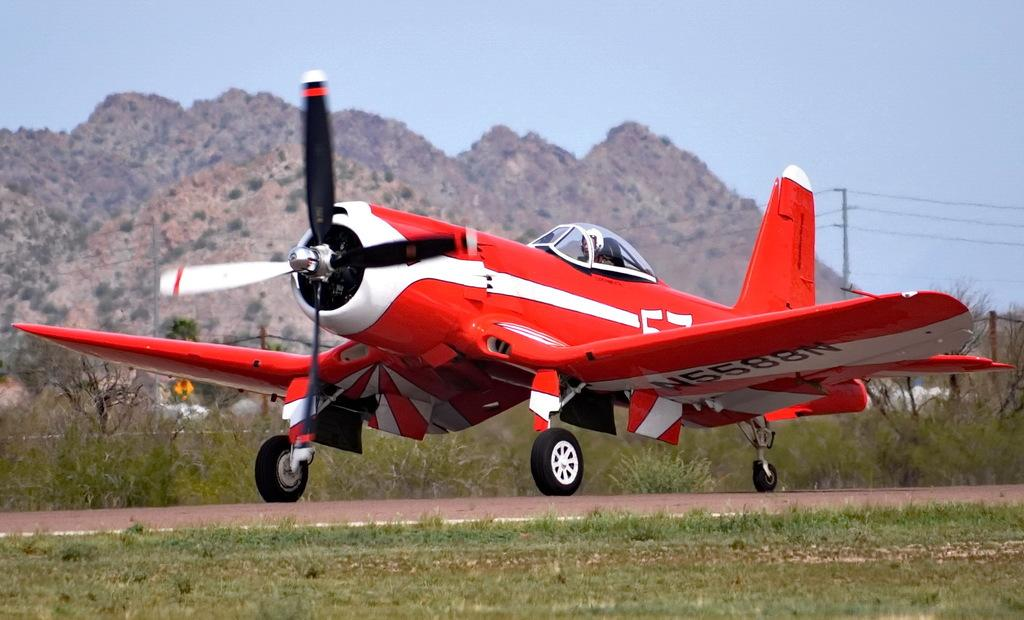Provide a one-sentence caption for the provided image. The red airplane taking off from the airfield has a reg number of N5588N. 